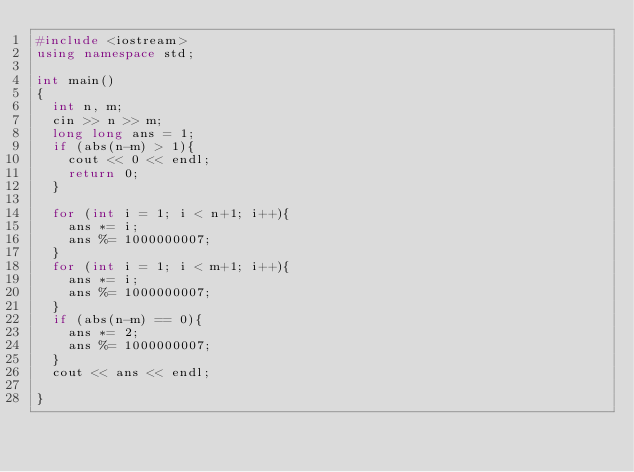<code> <loc_0><loc_0><loc_500><loc_500><_C++_>#include <iostream>
using namespace std;

int main()
{
	int n, m;
	cin >> n >> m;
	long long ans = 1;
	if (abs(n-m) > 1){
		cout << 0 << endl;
		return 0;
	}

	for (int i = 1; i < n+1; i++){
		ans *= i;
		ans %= 1000000007;
	}
	for (int i = 1; i < m+1; i++){
		ans *= i;
		ans %= 1000000007;
	}
	if (abs(n-m) == 0){
		ans *= 2;
		ans %= 1000000007;
	}
	cout << ans << endl;

}
</code> 